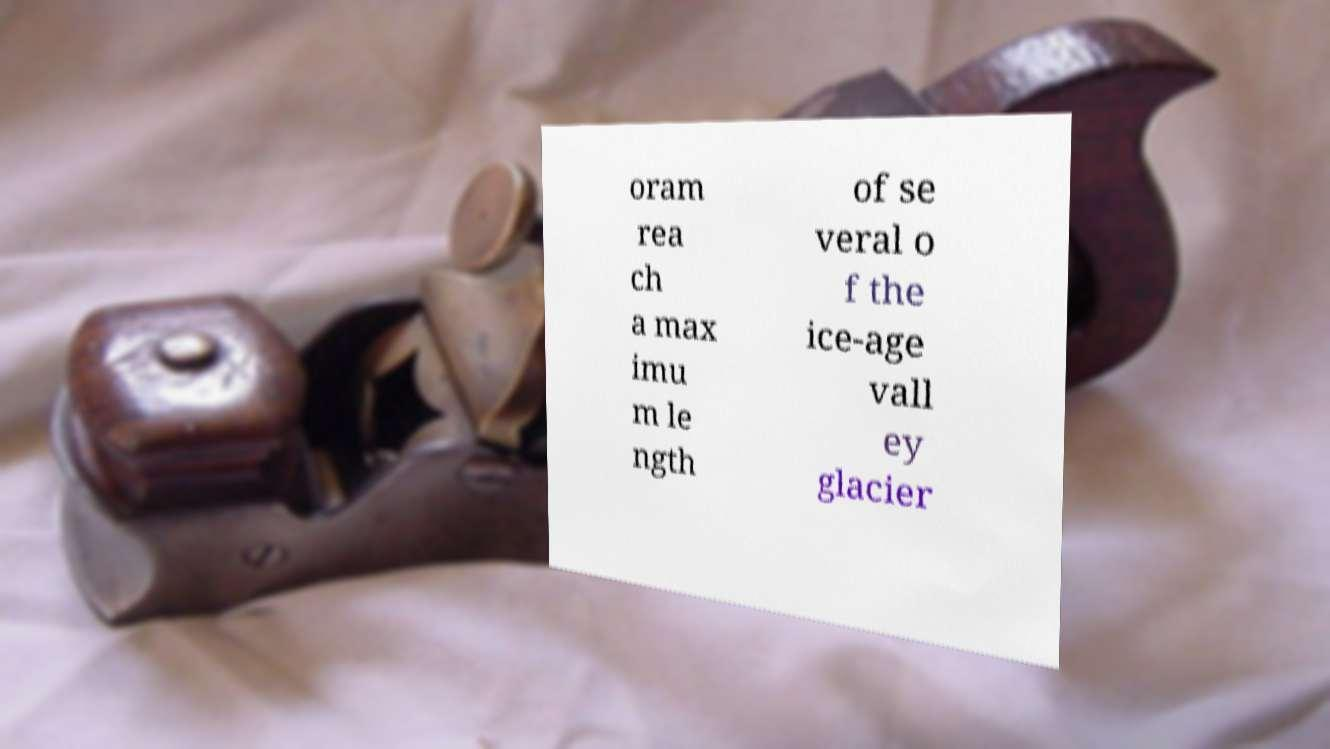Can you accurately transcribe the text from the provided image for me? oram rea ch a max imu m le ngth of se veral o f the ice-age vall ey glacier 